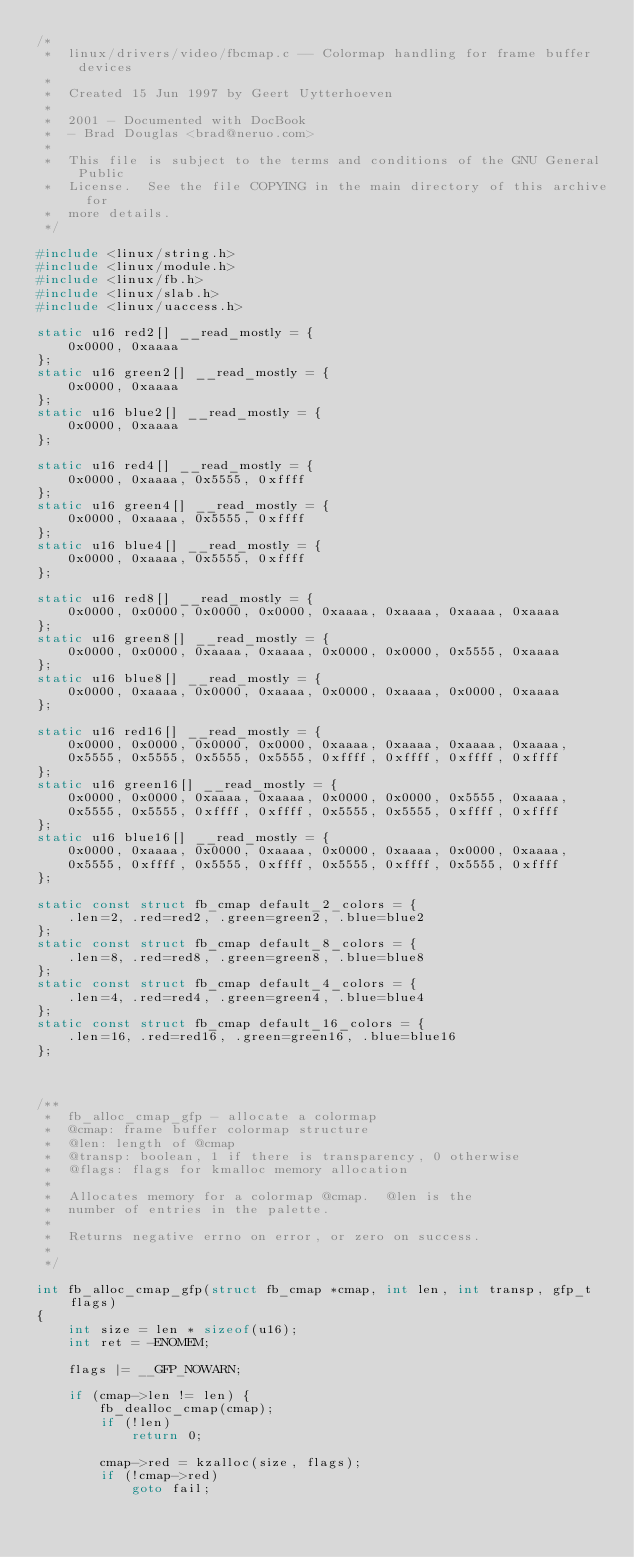<code> <loc_0><loc_0><loc_500><loc_500><_C_>/*
 *  linux/drivers/video/fbcmap.c -- Colormap handling for frame buffer devices
 *
 *	Created 15 Jun 1997 by Geert Uytterhoeven
 *
 *	2001 - Documented with DocBook
 *	- Brad Douglas <brad@neruo.com>
 *
 *  This file is subject to the terms and conditions of the GNU General Public
 *  License.  See the file COPYING in the main directory of this archive for
 *  more details.
 */

#include <linux/string.h>
#include <linux/module.h>
#include <linux/fb.h>
#include <linux/slab.h>
#include <linux/uaccess.h>

static u16 red2[] __read_mostly = {
    0x0000, 0xaaaa
};
static u16 green2[] __read_mostly = {
    0x0000, 0xaaaa
};
static u16 blue2[] __read_mostly = {
    0x0000, 0xaaaa
};

static u16 red4[] __read_mostly = {
    0x0000, 0xaaaa, 0x5555, 0xffff
};
static u16 green4[] __read_mostly = {
    0x0000, 0xaaaa, 0x5555, 0xffff
};
static u16 blue4[] __read_mostly = {
    0x0000, 0xaaaa, 0x5555, 0xffff
};

static u16 red8[] __read_mostly = {
    0x0000, 0x0000, 0x0000, 0x0000, 0xaaaa, 0xaaaa, 0xaaaa, 0xaaaa
};
static u16 green8[] __read_mostly = {
    0x0000, 0x0000, 0xaaaa, 0xaaaa, 0x0000, 0x0000, 0x5555, 0xaaaa
};
static u16 blue8[] __read_mostly = {
    0x0000, 0xaaaa, 0x0000, 0xaaaa, 0x0000, 0xaaaa, 0x0000, 0xaaaa
};

static u16 red16[] __read_mostly = {
    0x0000, 0x0000, 0x0000, 0x0000, 0xaaaa, 0xaaaa, 0xaaaa, 0xaaaa,
    0x5555, 0x5555, 0x5555, 0x5555, 0xffff, 0xffff, 0xffff, 0xffff
};
static u16 green16[] __read_mostly = {
    0x0000, 0x0000, 0xaaaa, 0xaaaa, 0x0000, 0x0000, 0x5555, 0xaaaa,
    0x5555, 0x5555, 0xffff, 0xffff, 0x5555, 0x5555, 0xffff, 0xffff
};
static u16 blue16[] __read_mostly = {
    0x0000, 0xaaaa, 0x0000, 0xaaaa, 0x0000, 0xaaaa, 0x0000, 0xaaaa,
    0x5555, 0xffff, 0x5555, 0xffff, 0x5555, 0xffff, 0x5555, 0xffff
};

static const struct fb_cmap default_2_colors = {
    .len=2, .red=red2, .green=green2, .blue=blue2
};
static const struct fb_cmap default_8_colors = {
    .len=8, .red=red8, .green=green8, .blue=blue8
};
static const struct fb_cmap default_4_colors = {
    .len=4, .red=red4, .green=green4, .blue=blue4
};
static const struct fb_cmap default_16_colors = {
    .len=16, .red=red16, .green=green16, .blue=blue16
};



/**
 *	fb_alloc_cmap_gfp - allocate a colormap
 *	@cmap: frame buffer colormap structure
 *	@len: length of @cmap
 *	@transp: boolean, 1 if there is transparency, 0 otherwise
 *	@flags: flags for kmalloc memory allocation
 *
 *	Allocates memory for a colormap @cmap.  @len is the
 *	number of entries in the palette.
 *
 *	Returns negative errno on error, or zero on success.
 *
 */

int fb_alloc_cmap_gfp(struct fb_cmap *cmap, int len, int transp, gfp_t flags)
{
	int size = len * sizeof(u16);
	int ret = -ENOMEM;

	flags |= __GFP_NOWARN;

	if (cmap->len != len) {
		fb_dealloc_cmap(cmap);
		if (!len)
			return 0;

		cmap->red = kzalloc(size, flags);
		if (!cmap->red)
			goto fail;</code> 